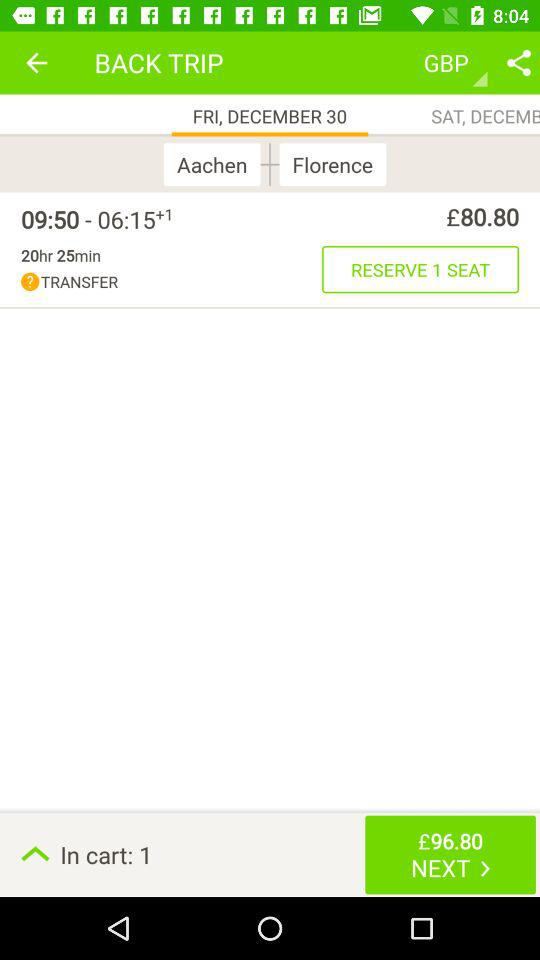On which tab am I now? You are now on the "FRI, DECEMBER 30" tab. 